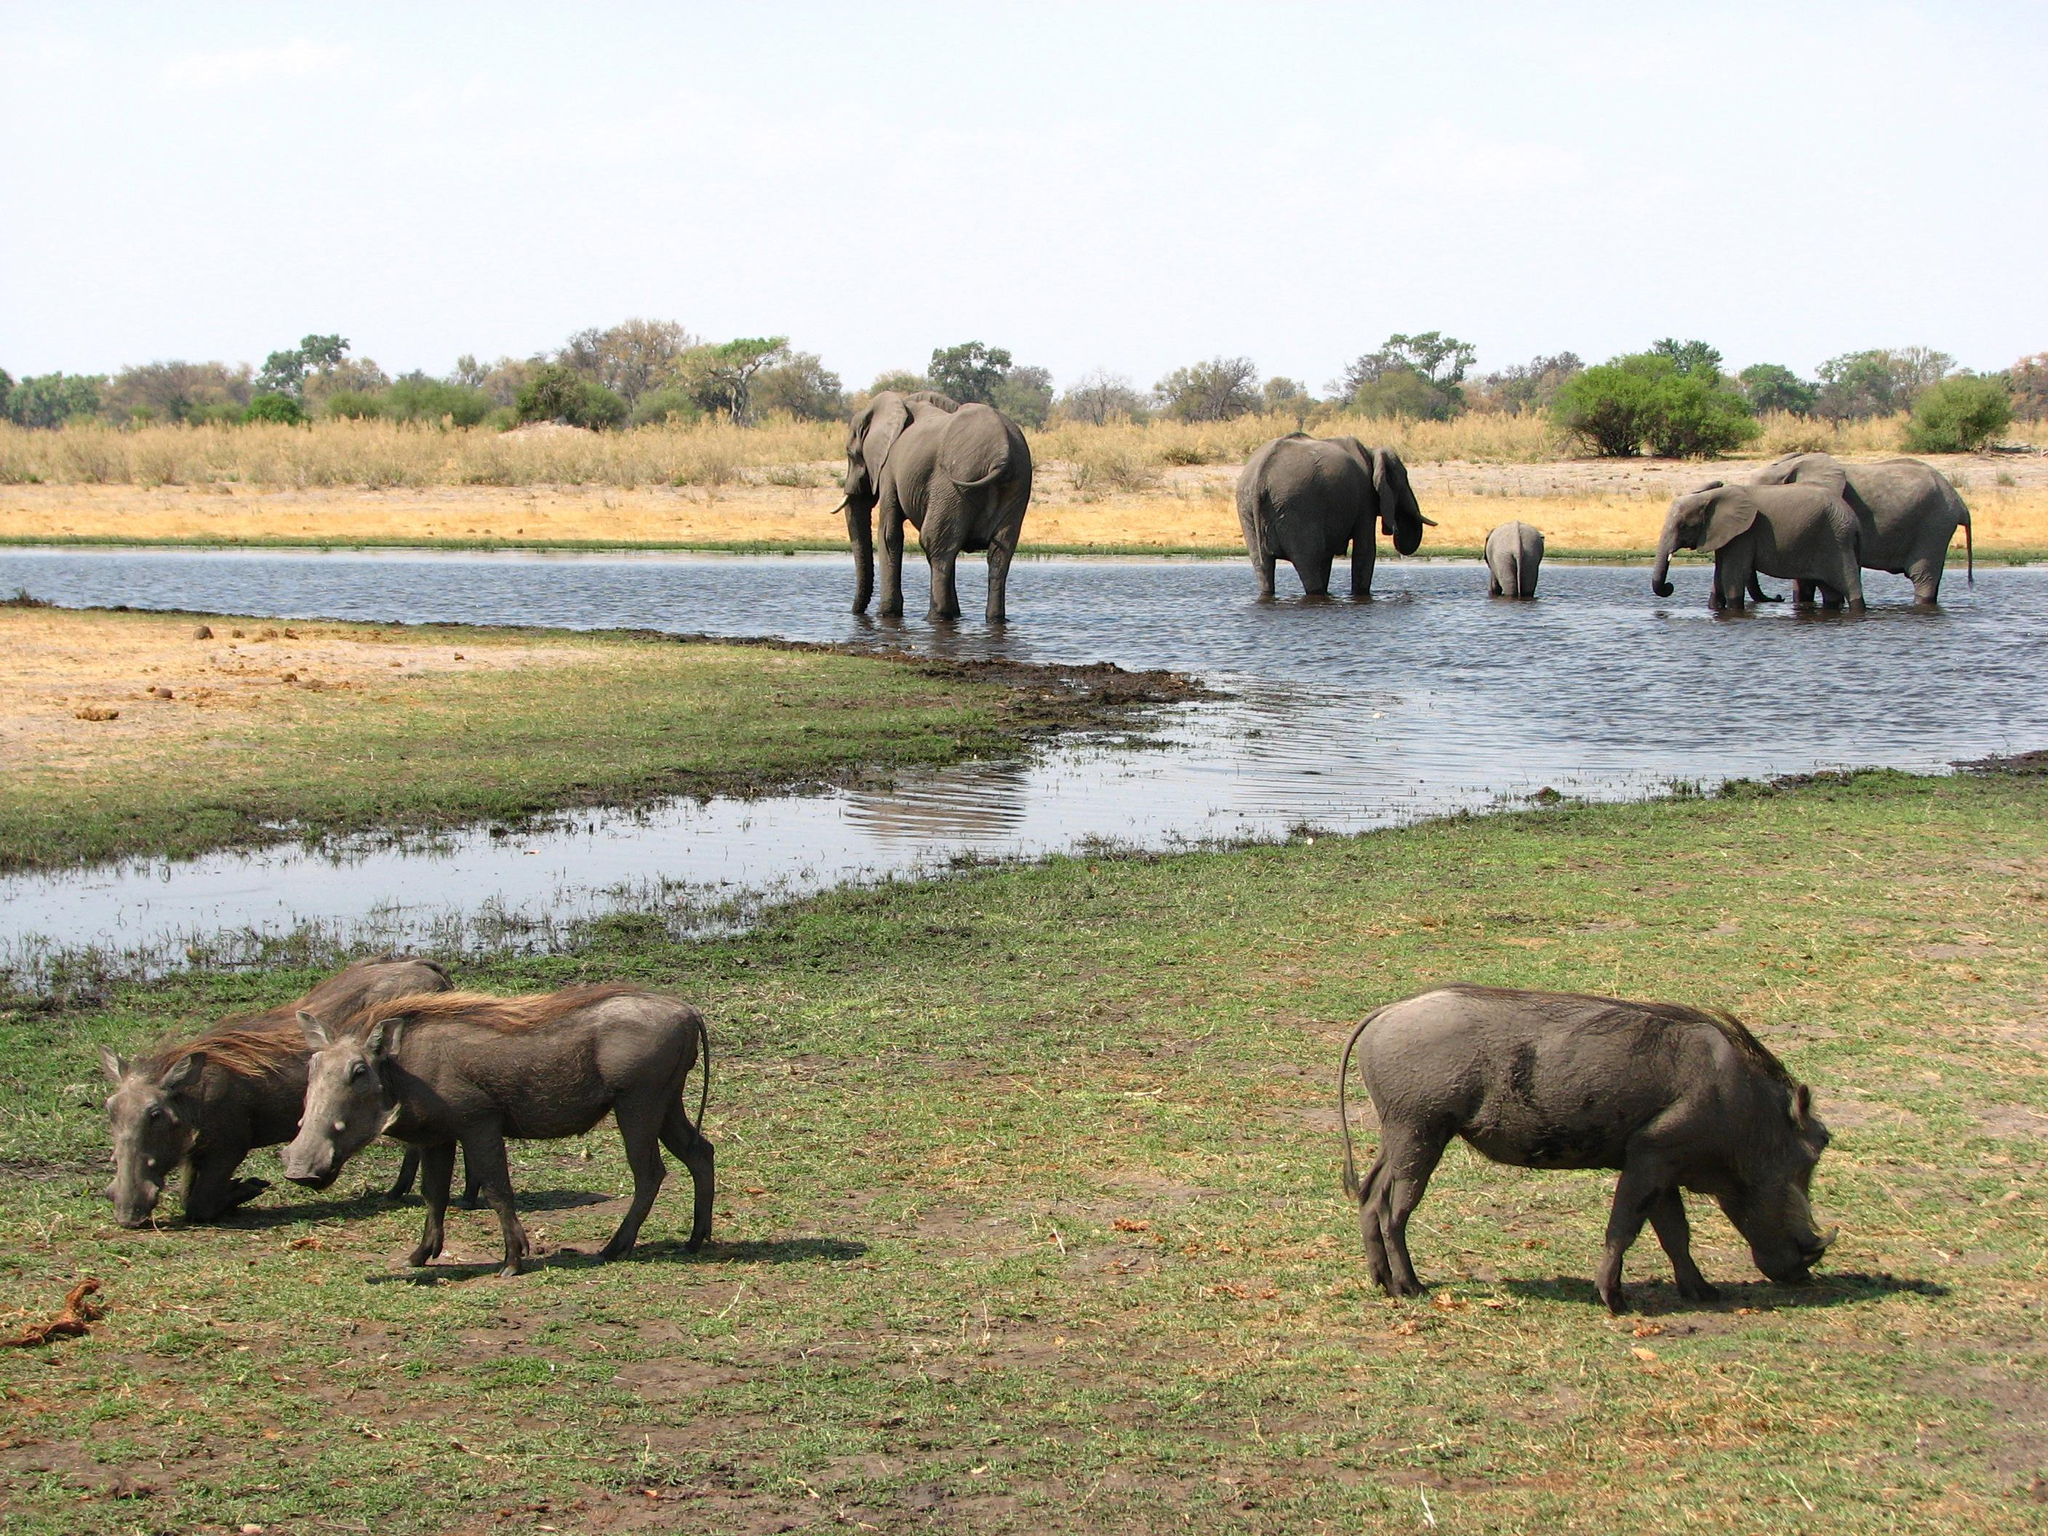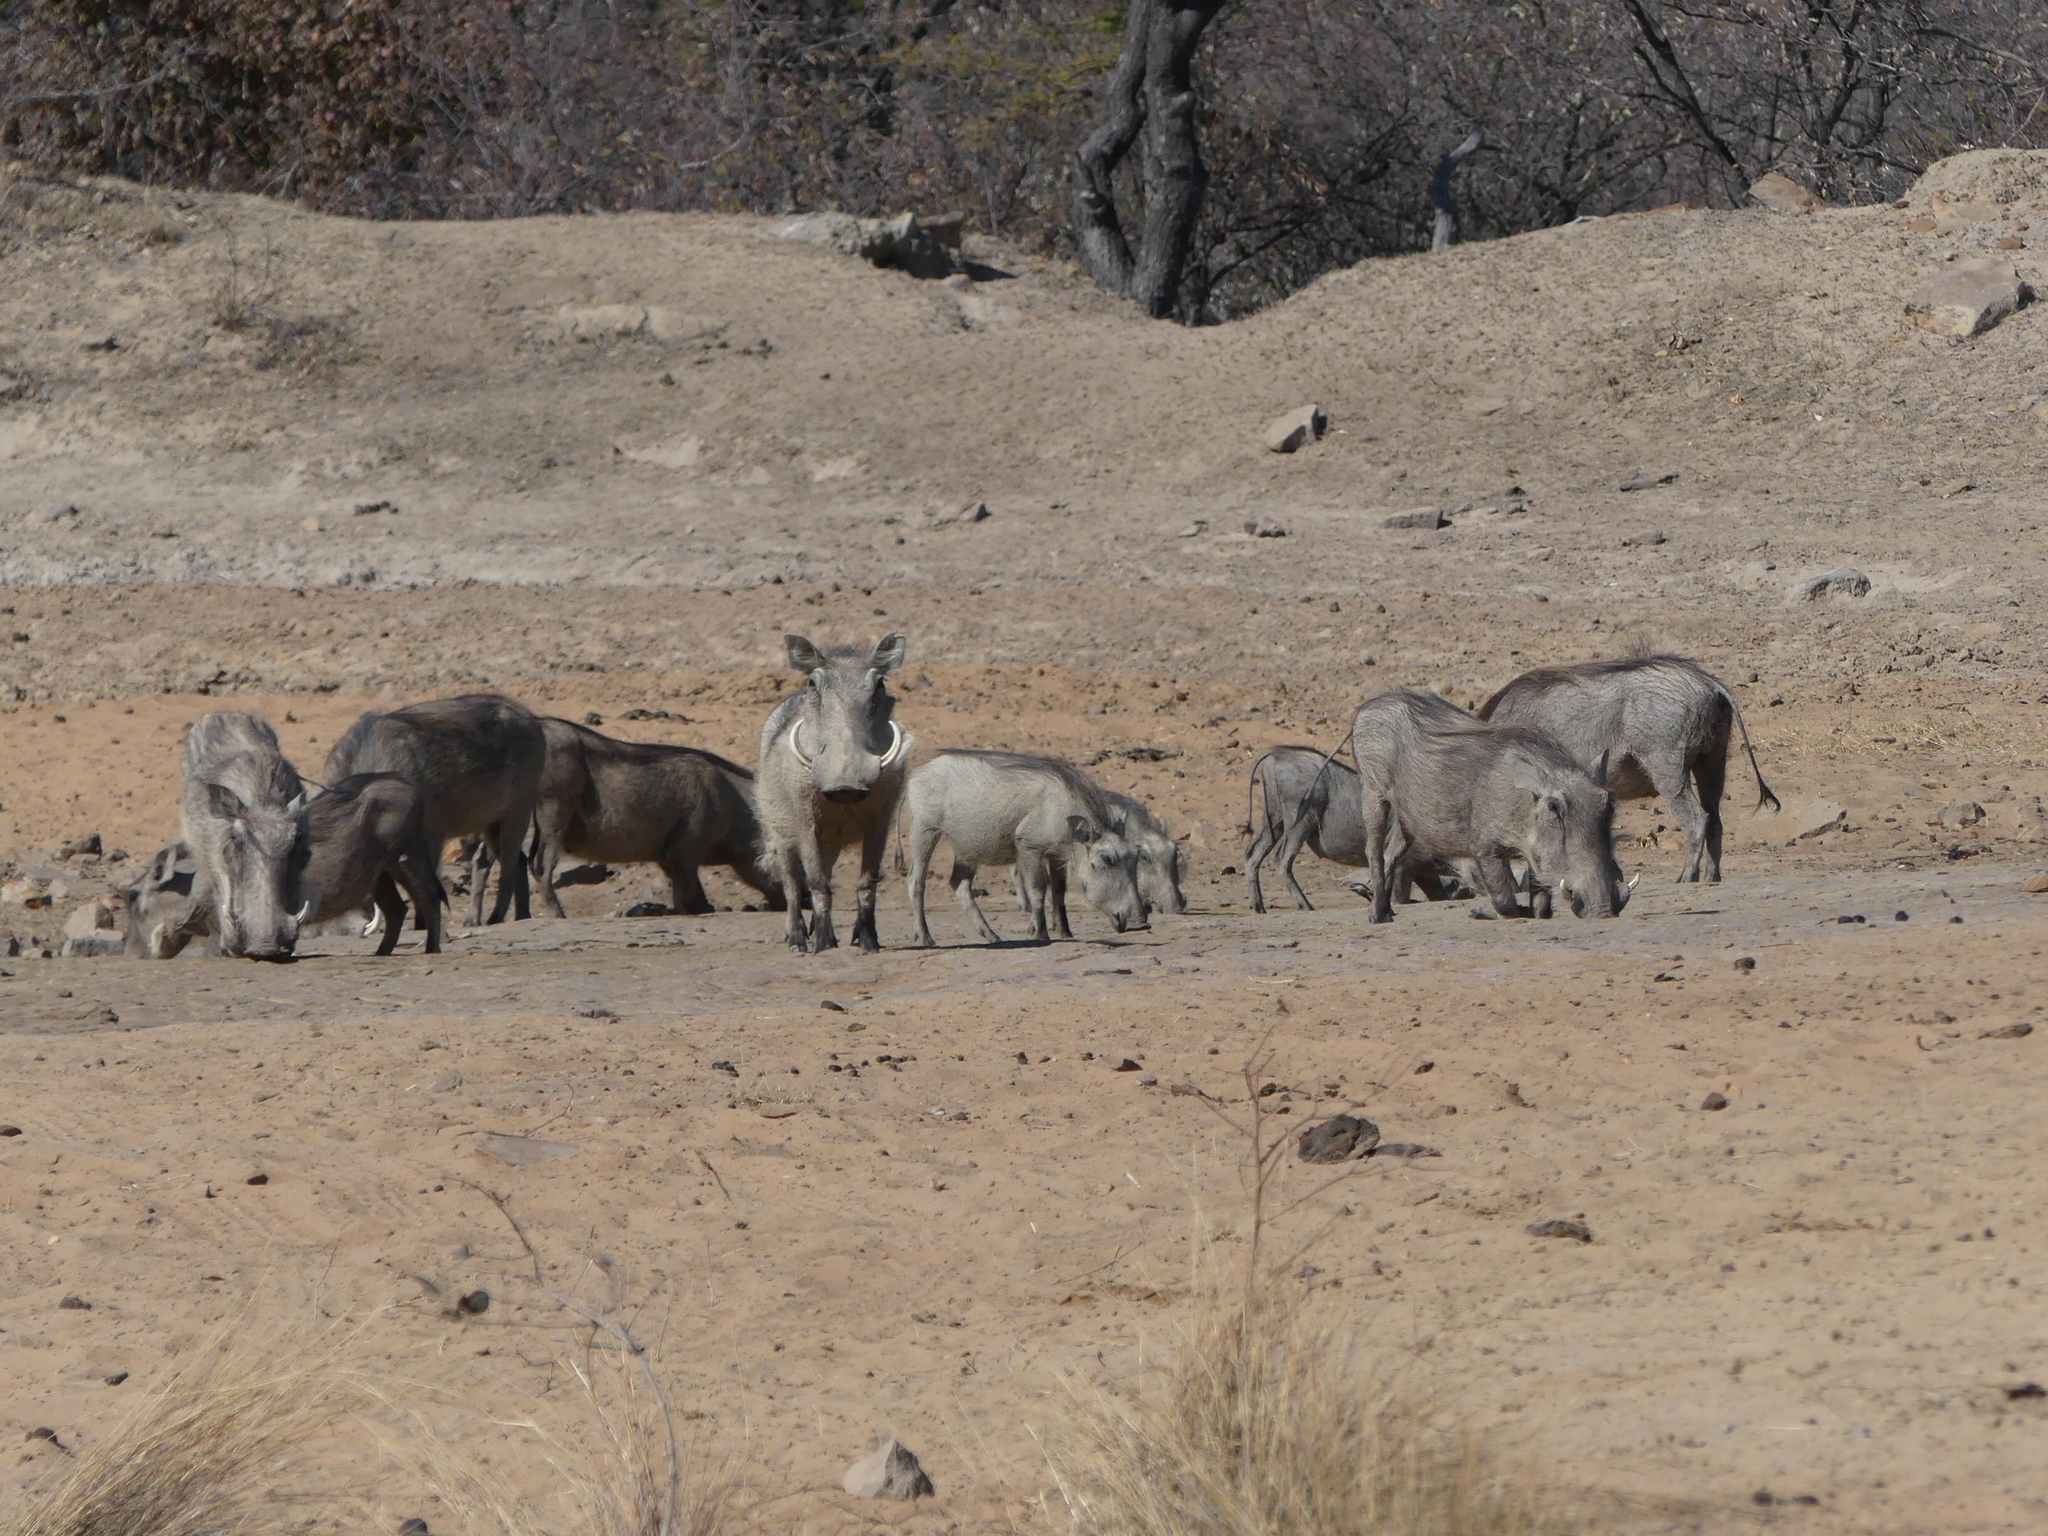The first image is the image on the left, the second image is the image on the right. Considering the images on both sides, is "The warthogs in one image are next to a body of water." valid? Answer yes or no. Yes. The first image is the image on the left, the second image is the image on the right. For the images shown, is this caption "Warthogs are standing in front of a body of nearby visible water, in one image." true? Answer yes or no. Yes. 